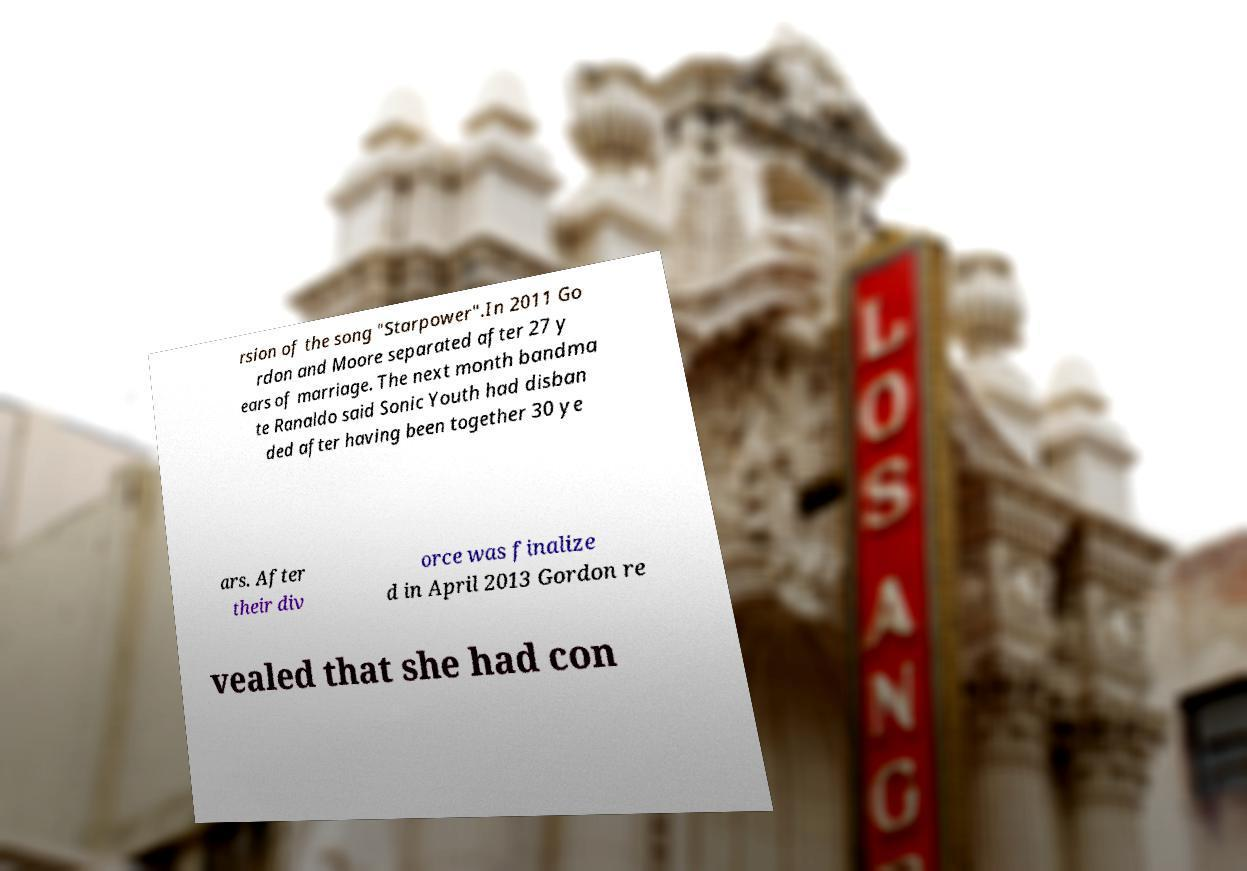I need the written content from this picture converted into text. Can you do that? rsion of the song "Starpower".In 2011 Go rdon and Moore separated after 27 y ears of marriage. The next month bandma te Ranaldo said Sonic Youth had disban ded after having been together 30 ye ars. After their div orce was finalize d in April 2013 Gordon re vealed that she had con 